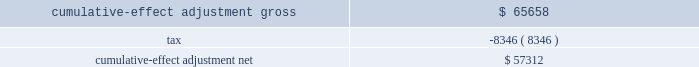Other-than-temporary impairments on investment securities .
In april 2009 , the fasb revised the authoritative guidance for the recognition and presentation of other-than-temporary impairments .
This new guidance amends the recognition guidance for other-than-temporary impairments of debt securities and expands the financial statement disclosures for other-than-temporary impairments on debt and equity securities .
For available for sale debt securities that the company has no intent to sell and more likely than not will not be required to sell prior to recovery , only the credit loss component of the impairment would be recognized in earnings , while the rest of the fair value loss would be recognized in accumulated other comprehensive income ( loss ) .
The company adopted this guidance effective april 1 , 2009 .
Upon adoption the company recognized a cumulative-effect adjustment increase in retained earnings ( deficit ) and decrease in accumulated other comprehensive income ( loss ) as follows : ( dollars in thousands ) .
Measurement of fair value in inactive markets .
In april 2009 , the fasb revised the authoritative guidance for fair value measurements and disclosures , which reaffirms that fair value is the price that would be received to sell an asset or paid to transfer a liability in an orderly transaction between market participants at the measurement date under current market conditions .
It also reaffirms the need to use judgment in determining if a formerly active market has become inactive and in determining fair values when the market has become inactive .
There was no impact to the company 2019s financial statements upon adoption .
Fair value disclosures about pension plan assets .
In december 2008 , the fasb revised the authoritative guidance for employers 2019 disclosures about pension plan assets .
This new guidance requires additional disclosures about the components of plan assets , investment strategies for plan assets and significant concentrations of risk within plan assets .
The company , in conjunction with fair value measurement of plan assets , separated plan assets into the three fair value hierarchy levels and provided a roll forward of the changes in fair value of plan assets classified as level 3 in the 2009 annual consolidated financial statements .
These disclosures had no effect on the company 2019s accounting for plan benefits and obligations .
Revisions to earnings per share calculation .
In june 2008 , the fasb revised the authoritative guidance for earnings per share for determining whether instruments granted in share-based payment transactions are participating securities .
This new guidance requires unvested share-based payment awards that contain non- forfeitable rights to dividends be considered as a separate class of common stock and included in the earnings per share calculation using the two-class method .
The company 2019s restricted share awards meet this definition and are therefore included in the basic earnings per share calculation .
Additional disclosures for derivative instruments .
In march 2008 , the fasb issued authoritative guidance for derivative instruments and hedging activities , which requires enhanced disclosures on derivative instruments and hedged items .
On january 1 , 2009 , the company adopted the additional disclosure for the equity index put options .
No comparative information for periods prior to the effective date was required .
This guidance had no impact on how the company records its derivatives. .
What is the tax rate on the cumulative-effect adjustment? 
Computations: (8346 / 65658)
Answer: 0.12711. 